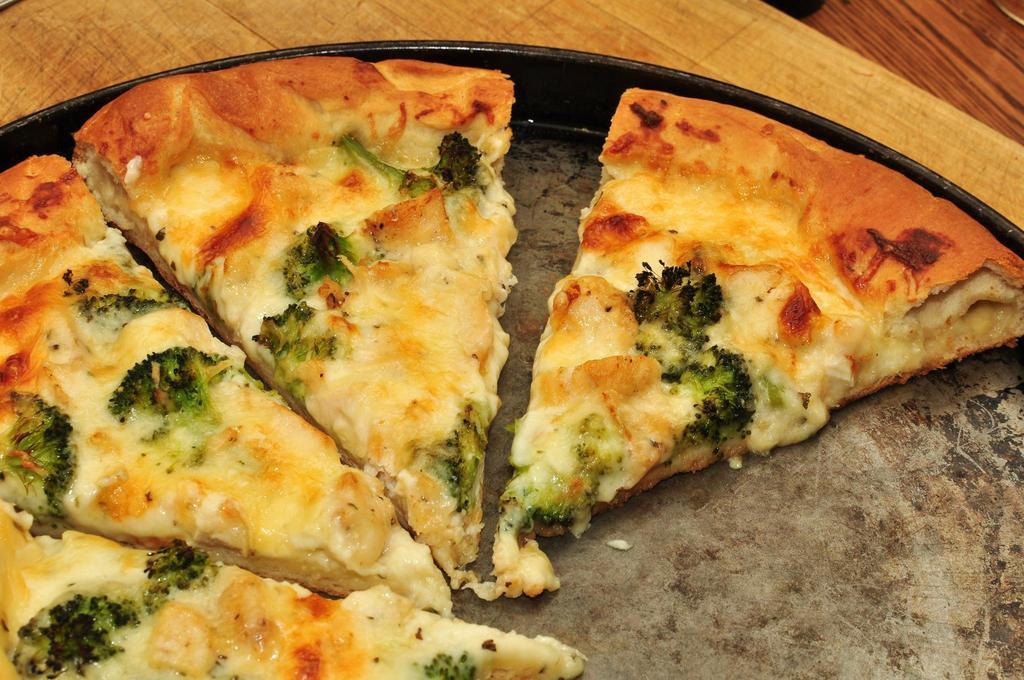What is on the table in the image? There is a plate on a table in the image. What is on the plate in the image? There are slices of pizza on the plate in the image. How many bananas are on the plate in the image? There are no bananas present on the plate in the image; it contains slices of pizza. What type of chickens can be seen walking around in the image? There are no chickens present in the image. 